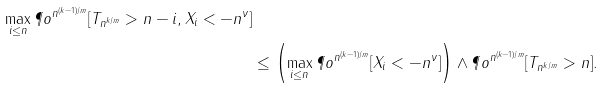Convert formula to latex. <formula><loc_0><loc_0><loc_500><loc_500>{ \max _ { i \leq n } \P o ^ { n ^ { ( k - 1 ) / m } } [ T _ { n ^ { k / m } } > n - i , X _ { i } < - n ^ { \nu } ] } \\ & \leq \left ( \max _ { i \leq n } \P o ^ { n ^ { ( k - 1 ) / m } } [ X _ { i } < - n ^ { \nu } ] \right ) \wedge \P o ^ { n ^ { ( k - 1 ) / m } } [ T _ { n ^ { k / m } } > n ] .</formula> 